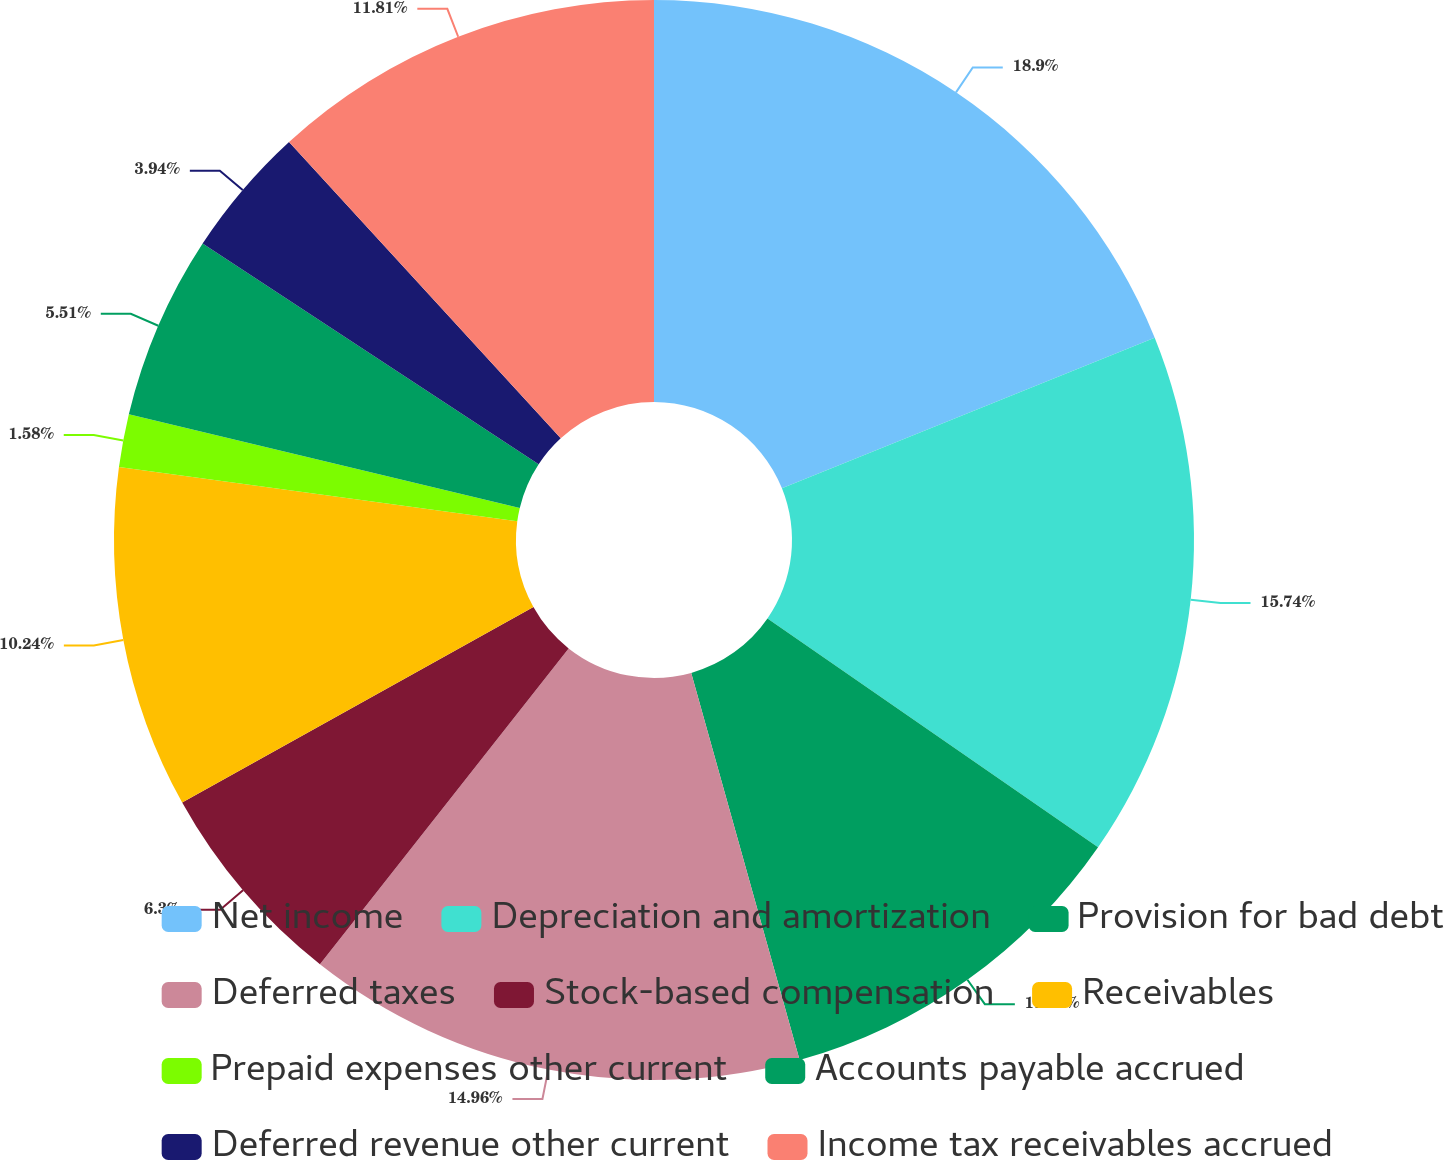<chart> <loc_0><loc_0><loc_500><loc_500><pie_chart><fcel>Net income<fcel>Depreciation and amortization<fcel>Provision for bad debt<fcel>Deferred taxes<fcel>Stock-based compensation<fcel>Receivables<fcel>Prepaid expenses other current<fcel>Accounts payable accrued<fcel>Deferred revenue other current<fcel>Income tax receivables accrued<nl><fcel>18.89%<fcel>15.74%<fcel>11.02%<fcel>14.96%<fcel>6.3%<fcel>10.24%<fcel>1.58%<fcel>5.51%<fcel>3.94%<fcel>11.81%<nl></chart> 